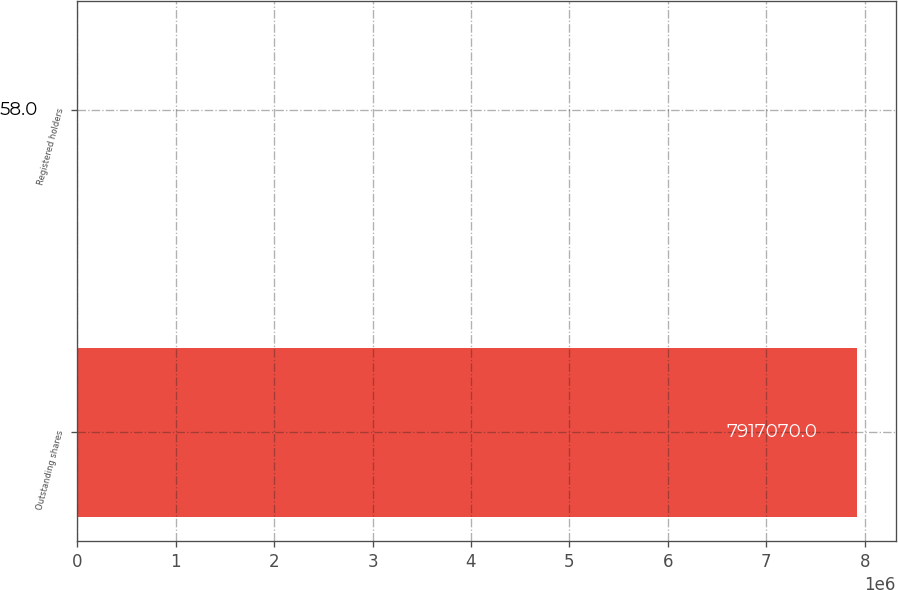Convert chart. <chart><loc_0><loc_0><loc_500><loc_500><bar_chart><fcel>Outstanding shares<fcel>Registered holders<nl><fcel>7.91707e+06<fcel>58<nl></chart> 